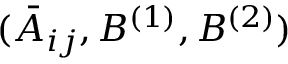<formula> <loc_0><loc_0><loc_500><loc_500>( \bar { A } _ { i j } , B ^ { ( 1 ) } , B ^ { ( 2 ) } )</formula> 